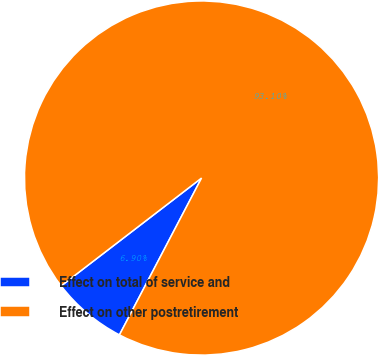Convert chart to OTSL. <chart><loc_0><loc_0><loc_500><loc_500><pie_chart><fcel>Effect on total of service and<fcel>Effect on other postretirement<nl><fcel>6.9%<fcel>93.1%<nl></chart> 